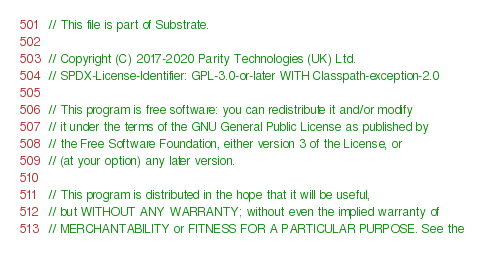<code> <loc_0><loc_0><loc_500><loc_500><_Rust_>// This file is part of Substrate.

// Copyright (C) 2017-2020 Parity Technologies (UK) Ltd.
// SPDX-License-Identifier: GPL-3.0-or-later WITH Classpath-exception-2.0

// This program is free software: you can redistribute it and/or modify
// it under the terms of the GNU General Public License as published by
// the Free Software Foundation, either version 3 of the License, or
// (at your option) any later version.

// This program is distributed in the hope that it will be useful,
// but WITHOUT ANY WARRANTY; without even the implied warranty of
// MERCHANTABILITY or FITNESS FOR A PARTICULAR PURPOSE. See the</code> 